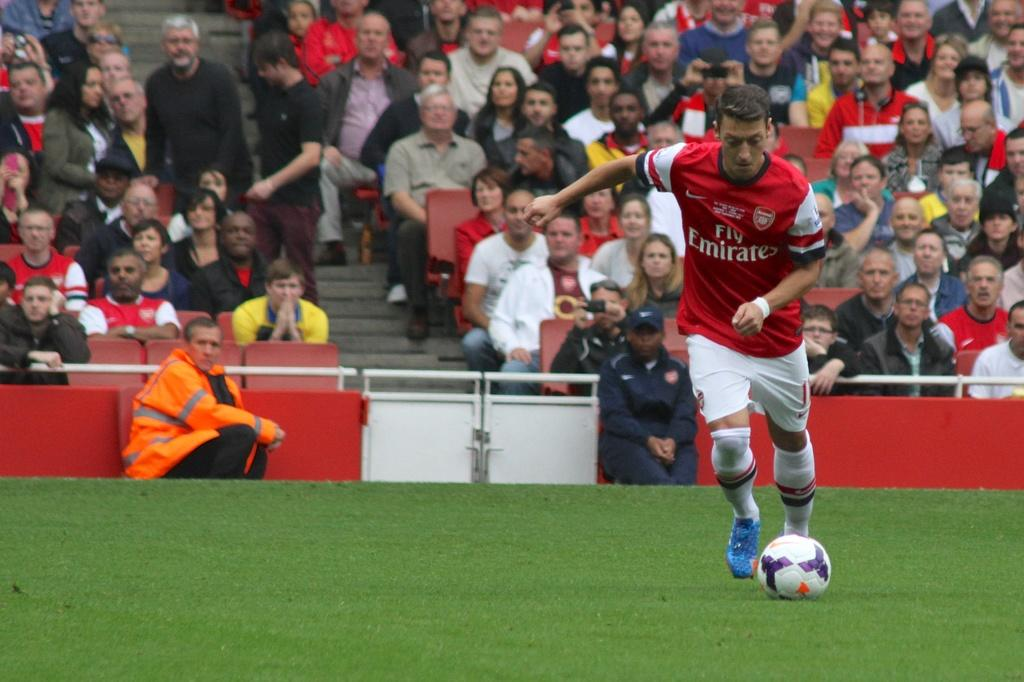<image>
Provide a brief description of the given image. The arsenal player shown is sponsored by Fly Emirates. 